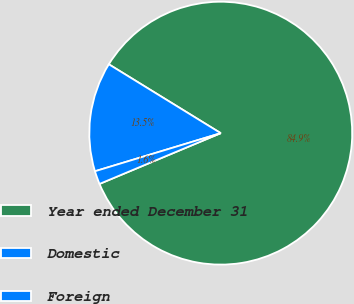<chart> <loc_0><loc_0><loc_500><loc_500><pie_chart><fcel>Year ended December 31<fcel>Domestic<fcel>Foreign<nl><fcel>84.91%<fcel>13.46%<fcel>1.63%<nl></chart> 